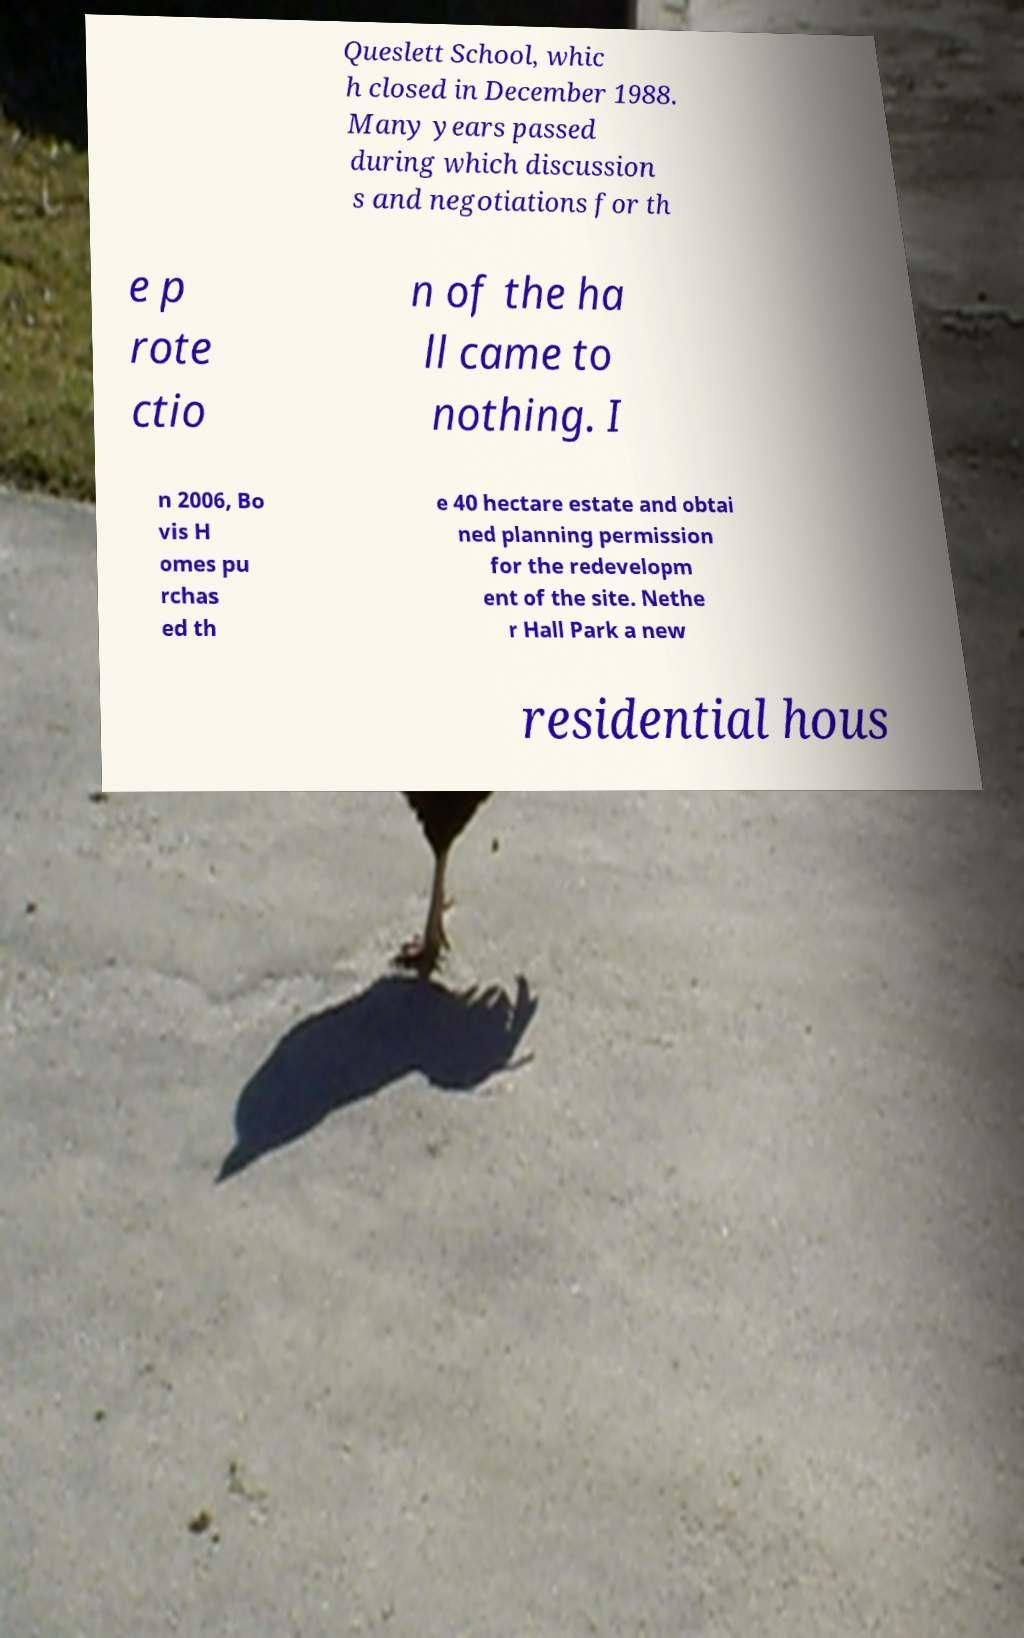I need the written content from this picture converted into text. Can you do that? Queslett School, whic h closed in December 1988. Many years passed during which discussion s and negotiations for th e p rote ctio n of the ha ll came to nothing. I n 2006, Bo vis H omes pu rchas ed th e 40 hectare estate and obtai ned planning permission for the redevelopm ent of the site. Nethe r Hall Park a new residential hous 